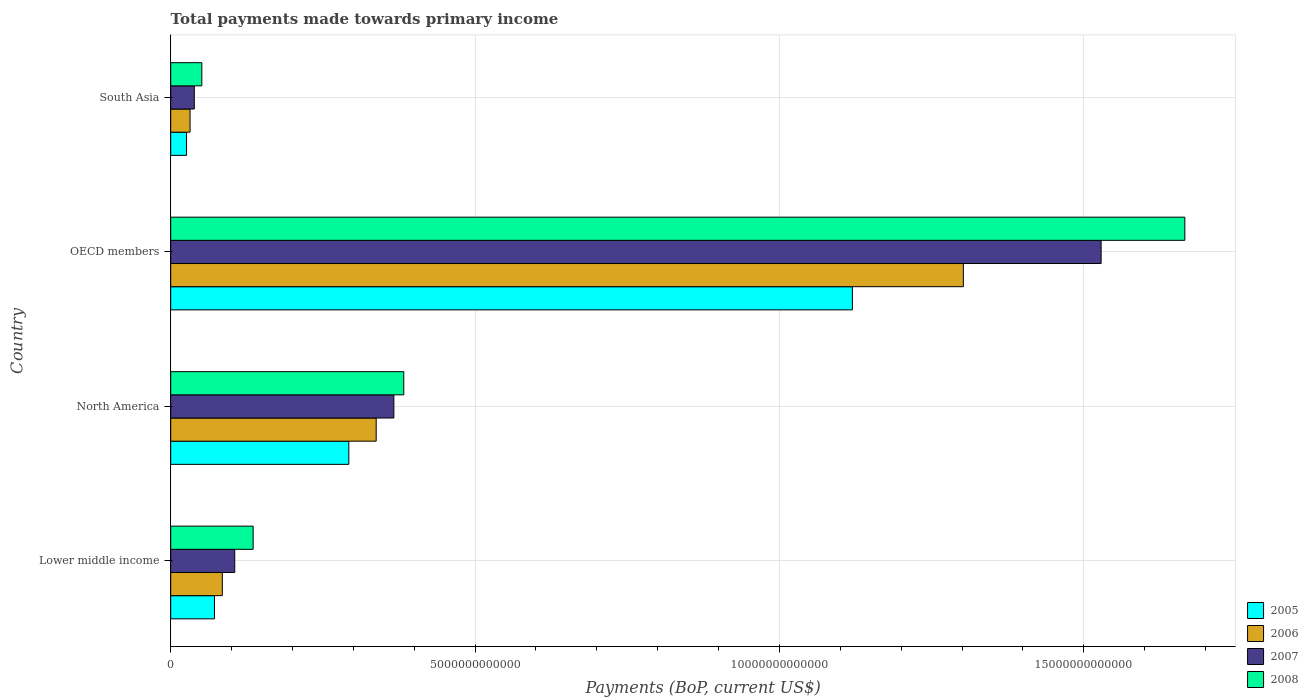How many different coloured bars are there?
Keep it short and to the point. 4. How many groups of bars are there?
Make the answer very short. 4. How many bars are there on the 1st tick from the top?
Give a very brief answer. 4. How many bars are there on the 1st tick from the bottom?
Keep it short and to the point. 4. In how many cases, is the number of bars for a given country not equal to the number of legend labels?
Your response must be concise. 0. What is the total payments made towards primary income in 2007 in OECD members?
Keep it short and to the point. 1.53e+13. Across all countries, what is the maximum total payments made towards primary income in 2005?
Keep it short and to the point. 1.12e+13. Across all countries, what is the minimum total payments made towards primary income in 2006?
Provide a short and direct response. 3.18e+11. In which country was the total payments made towards primary income in 2005 maximum?
Offer a very short reply. OECD members. In which country was the total payments made towards primary income in 2005 minimum?
Offer a terse response. South Asia. What is the total total payments made towards primary income in 2008 in the graph?
Ensure brevity in your answer.  2.24e+13. What is the difference between the total payments made towards primary income in 2005 in North America and that in South Asia?
Your answer should be very brief. 2.67e+12. What is the difference between the total payments made towards primary income in 2006 in Lower middle income and the total payments made towards primary income in 2005 in North America?
Your answer should be compact. -2.08e+12. What is the average total payments made towards primary income in 2005 per country?
Provide a succinct answer. 3.78e+12. What is the difference between the total payments made towards primary income in 2005 and total payments made towards primary income in 2006 in Lower middle income?
Your answer should be compact. -1.29e+11. In how many countries, is the total payments made towards primary income in 2007 greater than 15000000000000 US$?
Your answer should be very brief. 1. What is the ratio of the total payments made towards primary income in 2008 in North America to that in South Asia?
Provide a short and direct response. 7.49. What is the difference between the highest and the second highest total payments made towards primary income in 2006?
Provide a succinct answer. 9.65e+12. What is the difference between the highest and the lowest total payments made towards primary income in 2006?
Your answer should be very brief. 1.27e+13. Is it the case that in every country, the sum of the total payments made towards primary income in 2007 and total payments made towards primary income in 2006 is greater than the sum of total payments made towards primary income in 2008 and total payments made towards primary income in 2005?
Ensure brevity in your answer.  No. What does the 1st bar from the top in OECD members represents?
Keep it short and to the point. 2008. What does the 3rd bar from the bottom in OECD members represents?
Offer a very short reply. 2007. How many bars are there?
Your response must be concise. 16. How many countries are there in the graph?
Make the answer very short. 4. What is the difference between two consecutive major ticks on the X-axis?
Offer a very short reply. 5.00e+12. Does the graph contain any zero values?
Ensure brevity in your answer.  No. Where does the legend appear in the graph?
Your answer should be compact. Bottom right. What is the title of the graph?
Offer a terse response. Total payments made towards primary income. What is the label or title of the X-axis?
Ensure brevity in your answer.  Payments (BoP, current US$). What is the label or title of the Y-axis?
Your response must be concise. Country. What is the Payments (BoP, current US$) of 2005 in Lower middle income?
Provide a short and direct response. 7.19e+11. What is the Payments (BoP, current US$) in 2006 in Lower middle income?
Ensure brevity in your answer.  8.48e+11. What is the Payments (BoP, current US$) of 2007 in Lower middle income?
Offer a terse response. 1.05e+12. What is the Payments (BoP, current US$) in 2008 in Lower middle income?
Provide a short and direct response. 1.35e+12. What is the Payments (BoP, current US$) of 2005 in North America?
Your response must be concise. 2.93e+12. What is the Payments (BoP, current US$) in 2006 in North America?
Offer a very short reply. 3.38e+12. What is the Payments (BoP, current US$) in 2007 in North America?
Your answer should be compact. 3.67e+12. What is the Payments (BoP, current US$) in 2008 in North America?
Ensure brevity in your answer.  3.83e+12. What is the Payments (BoP, current US$) of 2005 in OECD members?
Keep it short and to the point. 1.12e+13. What is the Payments (BoP, current US$) in 2006 in OECD members?
Offer a very short reply. 1.30e+13. What is the Payments (BoP, current US$) in 2007 in OECD members?
Your response must be concise. 1.53e+13. What is the Payments (BoP, current US$) in 2008 in OECD members?
Provide a succinct answer. 1.67e+13. What is the Payments (BoP, current US$) of 2005 in South Asia?
Give a very brief answer. 2.61e+11. What is the Payments (BoP, current US$) in 2006 in South Asia?
Make the answer very short. 3.18e+11. What is the Payments (BoP, current US$) of 2007 in South Asia?
Keep it short and to the point. 3.88e+11. What is the Payments (BoP, current US$) of 2008 in South Asia?
Your answer should be compact. 5.11e+11. Across all countries, what is the maximum Payments (BoP, current US$) in 2005?
Your answer should be very brief. 1.12e+13. Across all countries, what is the maximum Payments (BoP, current US$) in 2006?
Your answer should be compact. 1.30e+13. Across all countries, what is the maximum Payments (BoP, current US$) of 2007?
Your answer should be very brief. 1.53e+13. Across all countries, what is the maximum Payments (BoP, current US$) of 2008?
Offer a very short reply. 1.67e+13. Across all countries, what is the minimum Payments (BoP, current US$) of 2005?
Ensure brevity in your answer.  2.61e+11. Across all countries, what is the minimum Payments (BoP, current US$) in 2006?
Offer a terse response. 3.18e+11. Across all countries, what is the minimum Payments (BoP, current US$) in 2007?
Your answer should be very brief. 3.88e+11. Across all countries, what is the minimum Payments (BoP, current US$) in 2008?
Your answer should be compact. 5.11e+11. What is the total Payments (BoP, current US$) of 2005 in the graph?
Offer a terse response. 1.51e+13. What is the total Payments (BoP, current US$) in 2006 in the graph?
Your response must be concise. 1.76e+13. What is the total Payments (BoP, current US$) in 2007 in the graph?
Your response must be concise. 2.04e+13. What is the total Payments (BoP, current US$) of 2008 in the graph?
Keep it short and to the point. 2.24e+13. What is the difference between the Payments (BoP, current US$) in 2005 in Lower middle income and that in North America?
Ensure brevity in your answer.  -2.21e+12. What is the difference between the Payments (BoP, current US$) of 2006 in Lower middle income and that in North America?
Offer a terse response. -2.53e+12. What is the difference between the Payments (BoP, current US$) in 2007 in Lower middle income and that in North America?
Provide a succinct answer. -2.61e+12. What is the difference between the Payments (BoP, current US$) in 2008 in Lower middle income and that in North America?
Your answer should be compact. -2.47e+12. What is the difference between the Payments (BoP, current US$) of 2005 in Lower middle income and that in OECD members?
Give a very brief answer. -1.05e+13. What is the difference between the Payments (BoP, current US$) of 2006 in Lower middle income and that in OECD members?
Offer a very short reply. -1.22e+13. What is the difference between the Payments (BoP, current US$) of 2007 in Lower middle income and that in OECD members?
Make the answer very short. -1.42e+13. What is the difference between the Payments (BoP, current US$) in 2008 in Lower middle income and that in OECD members?
Offer a terse response. -1.53e+13. What is the difference between the Payments (BoP, current US$) of 2005 in Lower middle income and that in South Asia?
Your response must be concise. 4.59e+11. What is the difference between the Payments (BoP, current US$) in 2006 in Lower middle income and that in South Asia?
Offer a terse response. 5.30e+11. What is the difference between the Payments (BoP, current US$) of 2007 in Lower middle income and that in South Asia?
Provide a succinct answer. 6.64e+11. What is the difference between the Payments (BoP, current US$) of 2008 in Lower middle income and that in South Asia?
Ensure brevity in your answer.  8.43e+11. What is the difference between the Payments (BoP, current US$) in 2005 in North America and that in OECD members?
Keep it short and to the point. -8.27e+12. What is the difference between the Payments (BoP, current US$) of 2006 in North America and that in OECD members?
Your response must be concise. -9.65e+12. What is the difference between the Payments (BoP, current US$) of 2007 in North America and that in OECD members?
Your answer should be compact. -1.16e+13. What is the difference between the Payments (BoP, current US$) of 2008 in North America and that in OECD members?
Your response must be concise. -1.28e+13. What is the difference between the Payments (BoP, current US$) of 2005 in North America and that in South Asia?
Offer a very short reply. 2.67e+12. What is the difference between the Payments (BoP, current US$) of 2006 in North America and that in South Asia?
Your answer should be very brief. 3.06e+12. What is the difference between the Payments (BoP, current US$) in 2007 in North America and that in South Asia?
Make the answer very short. 3.28e+12. What is the difference between the Payments (BoP, current US$) of 2008 in North America and that in South Asia?
Your answer should be very brief. 3.32e+12. What is the difference between the Payments (BoP, current US$) in 2005 in OECD members and that in South Asia?
Make the answer very short. 1.09e+13. What is the difference between the Payments (BoP, current US$) in 2006 in OECD members and that in South Asia?
Provide a succinct answer. 1.27e+13. What is the difference between the Payments (BoP, current US$) of 2007 in OECD members and that in South Asia?
Keep it short and to the point. 1.49e+13. What is the difference between the Payments (BoP, current US$) in 2008 in OECD members and that in South Asia?
Offer a terse response. 1.61e+13. What is the difference between the Payments (BoP, current US$) of 2005 in Lower middle income and the Payments (BoP, current US$) of 2006 in North America?
Offer a terse response. -2.66e+12. What is the difference between the Payments (BoP, current US$) of 2005 in Lower middle income and the Payments (BoP, current US$) of 2007 in North America?
Your answer should be compact. -2.95e+12. What is the difference between the Payments (BoP, current US$) in 2005 in Lower middle income and the Payments (BoP, current US$) in 2008 in North America?
Ensure brevity in your answer.  -3.11e+12. What is the difference between the Payments (BoP, current US$) in 2006 in Lower middle income and the Payments (BoP, current US$) in 2007 in North America?
Provide a short and direct response. -2.82e+12. What is the difference between the Payments (BoP, current US$) in 2006 in Lower middle income and the Payments (BoP, current US$) in 2008 in North America?
Ensure brevity in your answer.  -2.98e+12. What is the difference between the Payments (BoP, current US$) in 2007 in Lower middle income and the Payments (BoP, current US$) in 2008 in North America?
Offer a very short reply. -2.78e+12. What is the difference between the Payments (BoP, current US$) of 2005 in Lower middle income and the Payments (BoP, current US$) of 2006 in OECD members?
Your response must be concise. -1.23e+13. What is the difference between the Payments (BoP, current US$) in 2005 in Lower middle income and the Payments (BoP, current US$) in 2007 in OECD members?
Ensure brevity in your answer.  -1.46e+13. What is the difference between the Payments (BoP, current US$) in 2005 in Lower middle income and the Payments (BoP, current US$) in 2008 in OECD members?
Provide a succinct answer. -1.59e+13. What is the difference between the Payments (BoP, current US$) of 2006 in Lower middle income and the Payments (BoP, current US$) of 2007 in OECD members?
Your response must be concise. -1.44e+13. What is the difference between the Payments (BoP, current US$) of 2006 in Lower middle income and the Payments (BoP, current US$) of 2008 in OECD members?
Provide a succinct answer. -1.58e+13. What is the difference between the Payments (BoP, current US$) of 2007 in Lower middle income and the Payments (BoP, current US$) of 2008 in OECD members?
Make the answer very short. -1.56e+13. What is the difference between the Payments (BoP, current US$) in 2005 in Lower middle income and the Payments (BoP, current US$) in 2006 in South Asia?
Provide a succinct answer. 4.01e+11. What is the difference between the Payments (BoP, current US$) in 2005 in Lower middle income and the Payments (BoP, current US$) in 2007 in South Asia?
Make the answer very short. 3.32e+11. What is the difference between the Payments (BoP, current US$) of 2005 in Lower middle income and the Payments (BoP, current US$) of 2008 in South Asia?
Provide a succinct answer. 2.08e+11. What is the difference between the Payments (BoP, current US$) in 2006 in Lower middle income and the Payments (BoP, current US$) in 2007 in South Asia?
Make the answer very short. 4.60e+11. What is the difference between the Payments (BoP, current US$) of 2006 in Lower middle income and the Payments (BoP, current US$) of 2008 in South Asia?
Your answer should be very brief. 3.37e+11. What is the difference between the Payments (BoP, current US$) of 2007 in Lower middle income and the Payments (BoP, current US$) of 2008 in South Asia?
Your answer should be compact. 5.41e+11. What is the difference between the Payments (BoP, current US$) in 2005 in North America and the Payments (BoP, current US$) in 2006 in OECD members?
Give a very brief answer. -1.01e+13. What is the difference between the Payments (BoP, current US$) in 2005 in North America and the Payments (BoP, current US$) in 2007 in OECD members?
Give a very brief answer. -1.24e+13. What is the difference between the Payments (BoP, current US$) of 2005 in North America and the Payments (BoP, current US$) of 2008 in OECD members?
Your answer should be very brief. -1.37e+13. What is the difference between the Payments (BoP, current US$) in 2006 in North America and the Payments (BoP, current US$) in 2007 in OECD members?
Provide a short and direct response. -1.19e+13. What is the difference between the Payments (BoP, current US$) in 2006 in North America and the Payments (BoP, current US$) in 2008 in OECD members?
Your answer should be compact. -1.33e+13. What is the difference between the Payments (BoP, current US$) in 2007 in North America and the Payments (BoP, current US$) in 2008 in OECD members?
Your answer should be very brief. -1.30e+13. What is the difference between the Payments (BoP, current US$) of 2005 in North America and the Payments (BoP, current US$) of 2006 in South Asia?
Ensure brevity in your answer.  2.61e+12. What is the difference between the Payments (BoP, current US$) in 2005 in North America and the Payments (BoP, current US$) in 2007 in South Asia?
Ensure brevity in your answer.  2.54e+12. What is the difference between the Payments (BoP, current US$) in 2005 in North America and the Payments (BoP, current US$) in 2008 in South Asia?
Offer a terse response. 2.41e+12. What is the difference between the Payments (BoP, current US$) of 2006 in North America and the Payments (BoP, current US$) of 2007 in South Asia?
Ensure brevity in your answer.  2.99e+12. What is the difference between the Payments (BoP, current US$) in 2006 in North America and the Payments (BoP, current US$) in 2008 in South Asia?
Offer a terse response. 2.86e+12. What is the difference between the Payments (BoP, current US$) in 2007 in North America and the Payments (BoP, current US$) in 2008 in South Asia?
Provide a succinct answer. 3.15e+12. What is the difference between the Payments (BoP, current US$) of 2005 in OECD members and the Payments (BoP, current US$) of 2006 in South Asia?
Make the answer very short. 1.09e+13. What is the difference between the Payments (BoP, current US$) in 2005 in OECD members and the Payments (BoP, current US$) in 2007 in South Asia?
Offer a terse response. 1.08e+13. What is the difference between the Payments (BoP, current US$) in 2005 in OECD members and the Payments (BoP, current US$) in 2008 in South Asia?
Offer a very short reply. 1.07e+13. What is the difference between the Payments (BoP, current US$) of 2006 in OECD members and the Payments (BoP, current US$) of 2007 in South Asia?
Keep it short and to the point. 1.26e+13. What is the difference between the Payments (BoP, current US$) of 2006 in OECD members and the Payments (BoP, current US$) of 2008 in South Asia?
Your answer should be compact. 1.25e+13. What is the difference between the Payments (BoP, current US$) in 2007 in OECD members and the Payments (BoP, current US$) in 2008 in South Asia?
Keep it short and to the point. 1.48e+13. What is the average Payments (BoP, current US$) of 2005 per country?
Your answer should be compact. 3.78e+12. What is the average Payments (BoP, current US$) of 2006 per country?
Offer a very short reply. 4.39e+12. What is the average Payments (BoP, current US$) of 2007 per country?
Keep it short and to the point. 5.10e+12. What is the average Payments (BoP, current US$) of 2008 per country?
Provide a short and direct response. 5.59e+12. What is the difference between the Payments (BoP, current US$) of 2005 and Payments (BoP, current US$) of 2006 in Lower middle income?
Offer a terse response. -1.29e+11. What is the difference between the Payments (BoP, current US$) in 2005 and Payments (BoP, current US$) in 2007 in Lower middle income?
Offer a terse response. -3.33e+11. What is the difference between the Payments (BoP, current US$) of 2005 and Payments (BoP, current US$) of 2008 in Lower middle income?
Offer a terse response. -6.35e+11. What is the difference between the Payments (BoP, current US$) in 2006 and Payments (BoP, current US$) in 2007 in Lower middle income?
Your answer should be very brief. -2.04e+11. What is the difference between the Payments (BoP, current US$) of 2006 and Payments (BoP, current US$) of 2008 in Lower middle income?
Give a very brief answer. -5.07e+11. What is the difference between the Payments (BoP, current US$) in 2007 and Payments (BoP, current US$) in 2008 in Lower middle income?
Give a very brief answer. -3.03e+11. What is the difference between the Payments (BoP, current US$) of 2005 and Payments (BoP, current US$) of 2006 in North America?
Keep it short and to the point. -4.49e+11. What is the difference between the Payments (BoP, current US$) in 2005 and Payments (BoP, current US$) in 2007 in North America?
Give a very brief answer. -7.40e+11. What is the difference between the Payments (BoP, current US$) of 2005 and Payments (BoP, current US$) of 2008 in North America?
Provide a short and direct response. -9.02e+11. What is the difference between the Payments (BoP, current US$) of 2006 and Payments (BoP, current US$) of 2007 in North America?
Your answer should be very brief. -2.91e+11. What is the difference between the Payments (BoP, current US$) in 2006 and Payments (BoP, current US$) in 2008 in North America?
Offer a terse response. -4.53e+11. What is the difference between the Payments (BoP, current US$) in 2007 and Payments (BoP, current US$) in 2008 in North America?
Offer a very short reply. -1.62e+11. What is the difference between the Payments (BoP, current US$) of 2005 and Payments (BoP, current US$) of 2006 in OECD members?
Provide a short and direct response. -1.82e+12. What is the difference between the Payments (BoP, current US$) of 2005 and Payments (BoP, current US$) of 2007 in OECD members?
Your response must be concise. -4.09e+12. What is the difference between the Payments (BoP, current US$) of 2005 and Payments (BoP, current US$) of 2008 in OECD members?
Offer a very short reply. -5.46e+12. What is the difference between the Payments (BoP, current US$) in 2006 and Payments (BoP, current US$) in 2007 in OECD members?
Make the answer very short. -2.26e+12. What is the difference between the Payments (BoP, current US$) in 2006 and Payments (BoP, current US$) in 2008 in OECD members?
Provide a succinct answer. -3.64e+12. What is the difference between the Payments (BoP, current US$) in 2007 and Payments (BoP, current US$) in 2008 in OECD members?
Provide a short and direct response. -1.38e+12. What is the difference between the Payments (BoP, current US$) of 2005 and Payments (BoP, current US$) of 2006 in South Asia?
Keep it short and to the point. -5.75e+1. What is the difference between the Payments (BoP, current US$) in 2005 and Payments (BoP, current US$) in 2007 in South Asia?
Your answer should be very brief. -1.27e+11. What is the difference between the Payments (BoP, current US$) in 2005 and Payments (BoP, current US$) in 2008 in South Asia?
Offer a very short reply. -2.51e+11. What is the difference between the Payments (BoP, current US$) in 2006 and Payments (BoP, current US$) in 2007 in South Asia?
Offer a very short reply. -6.95e+1. What is the difference between the Payments (BoP, current US$) in 2006 and Payments (BoP, current US$) in 2008 in South Asia?
Ensure brevity in your answer.  -1.93e+11. What is the difference between the Payments (BoP, current US$) of 2007 and Payments (BoP, current US$) of 2008 in South Asia?
Provide a succinct answer. -1.24e+11. What is the ratio of the Payments (BoP, current US$) of 2005 in Lower middle income to that in North America?
Your answer should be very brief. 0.25. What is the ratio of the Payments (BoP, current US$) of 2006 in Lower middle income to that in North America?
Make the answer very short. 0.25. What is the ratio of the Payments (BoP, current US$) in 2007 in Lower middle income to that in North America?
Your answer should be compact. 0.29. What is the ratio of the Payments (BoP, current US$) of 2008 in Lower middle income to that in North America?
Provide a short and direct response. 0.35. What is the ratio of the Payments (BoP, current US$) in 2005 in Lower middle income to that in OECD members?
Provide a short and direct response. 0.06. What is the ratio of the Payments (BoP, current US$) in 2006 in Lower middle income to that in OECD members?
Provide a succinct answer. 0.07. What is the ratio of the Payments (BoP, current US$) in 2007 in Lower middle income to that in OECD members?
Give a very brief answer. 0.07. What is the ratio of the Payments (BoP, current US$) in 2008 in Lower middle income to that in OECD members?
Provide a short and direct response. 0.08. What is the ratio of the Payments (BoP, current US$) in 2005 in Lower middle income to that in South Asia?
Provide a succinct answer. 2.76. What is the ratio of the Payments (BoP, current US$) of 2006 in Lower middle income to that in South Asia?
Your answer should be compact. 2.67. What is the ratio of the Payments (BoP, current US$) in 2007 in Lower middle income to that in South Asia?
Your response must be concise. 2.71. What is the ratio of the Payments (BoP, current US$) in 2008 in Lower middle income to that in South Asia?
Offer a terse response. 2.65. What is the ratio of the Payments (BoP, current US$) of 2005 in North America to that in OECD members?
Your answer should be very brief. 0.26. What is the ratio of the Payments (BoP, current US$) in 2006 in North America to that in OECD members?
Offer a terse response. 0.26. What is the ratio of the Payments (BoP, current US$) in 2007 in North America to that in OECD members?
Provide a succinct answer. 0.24. What is the ratio of the Payments (BoP, current US$) of 2008 in North America to that in OECD members?
Your answer should be compact. 0.23. What is the ratio of the Payments (BoP, current US$) in 2005 in North America to that in South Asia?
Offer a very short reply. 11.23. What is the ratio of the Payments (BoP, current US$) of 2006 in North America to that in South Asia?
Give a very brief answer. 10.61. What is the ratio of the Payments (BoP, current US$) of 2007 in North America to that in South Asia?
Make the answer very short. 9.46. What is the ratio of the Payments (BoP, current US$) in 2008 in North America to that in South Asia?
Offer a terse response. 7.49. What is the ratio of the Payments (BoP, current US$) in 2005 in OECD members to that in South Asia?
Provide a succinct answer. 42.99. What is the ratio of the Payments (BoP, current US$) of 2006 in OECD members to that in South Asia?
Provide a short and direct response. 40.95. What is the ratio of the Payments (BoP, current US$) in 2007 in OECD members to that in South Asia?
Keep it short and to the point. 39.44. What is the ratio of the Payments (BoP, current US$) of 2008 in OECD members to that in South Asia?
Your response must be concise. 32.59. What is the difference between the highest and the second highest Payments (BoP, current US$) of 2005?
Give a very brief answer. 8.27e+12. What is the difference between the highest and the second highest Payments (BoP, current US$) of 2006?
Offer a terse response. 9.65e+12. What is the difference between the highest and the second highest Payments (BoP, current US$) in 2007?
Keep it short and to the point. 1.16e+13. What is the difference between the highest and the second highest Payments (BoP, current US$) of 2008?
Offer a terse response. 1.28e+13. What is the difference between the highest and the lowest Payments (BoP, current US$) of 2005?
Give a very brief answer. 1.09e+13. What is the difference between the highest and the lowest Payments (BoP, current US$) of 2006?
Your answer should be very brief. 1.27e+13. What is the difference between the highest and the lowest Payments (BoP, current US$) of 2007?
Provide a succinct answer. 1.49e+13. What is the difference between the highest and the lowest Payments (BoP, current US$) in 2008?
Keep it short and to the point. 1.61e+13. 